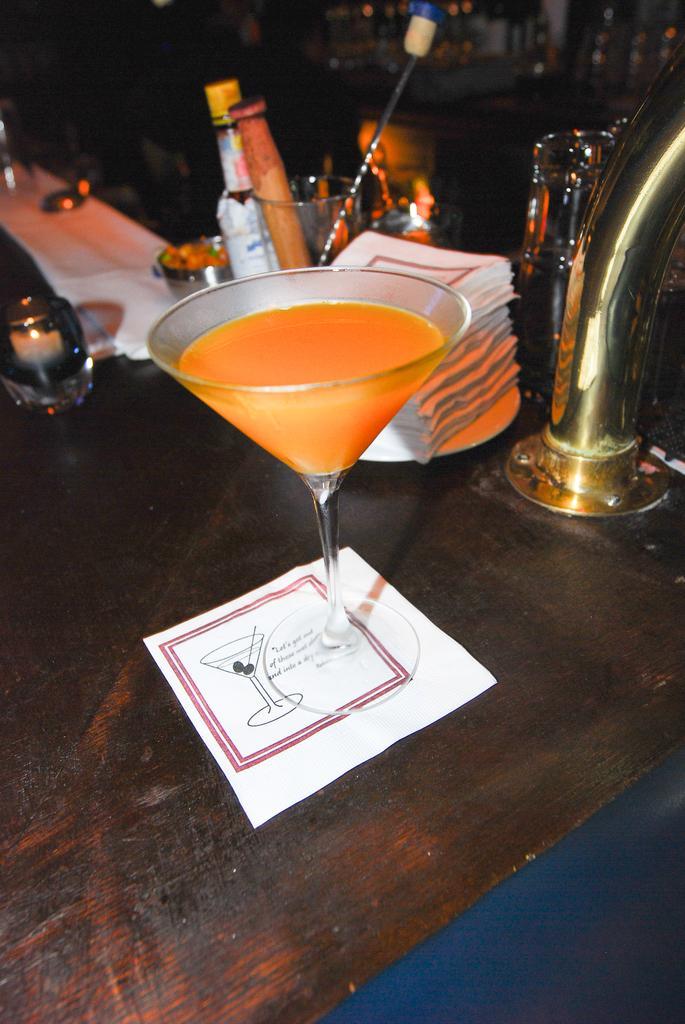Please provide a concise description of this image. In the image we can see the wooden surface on it there are many other things, like bottles, glasses and liquid in the glass, paper, plate, tissue papers and the background is slightly dark. 